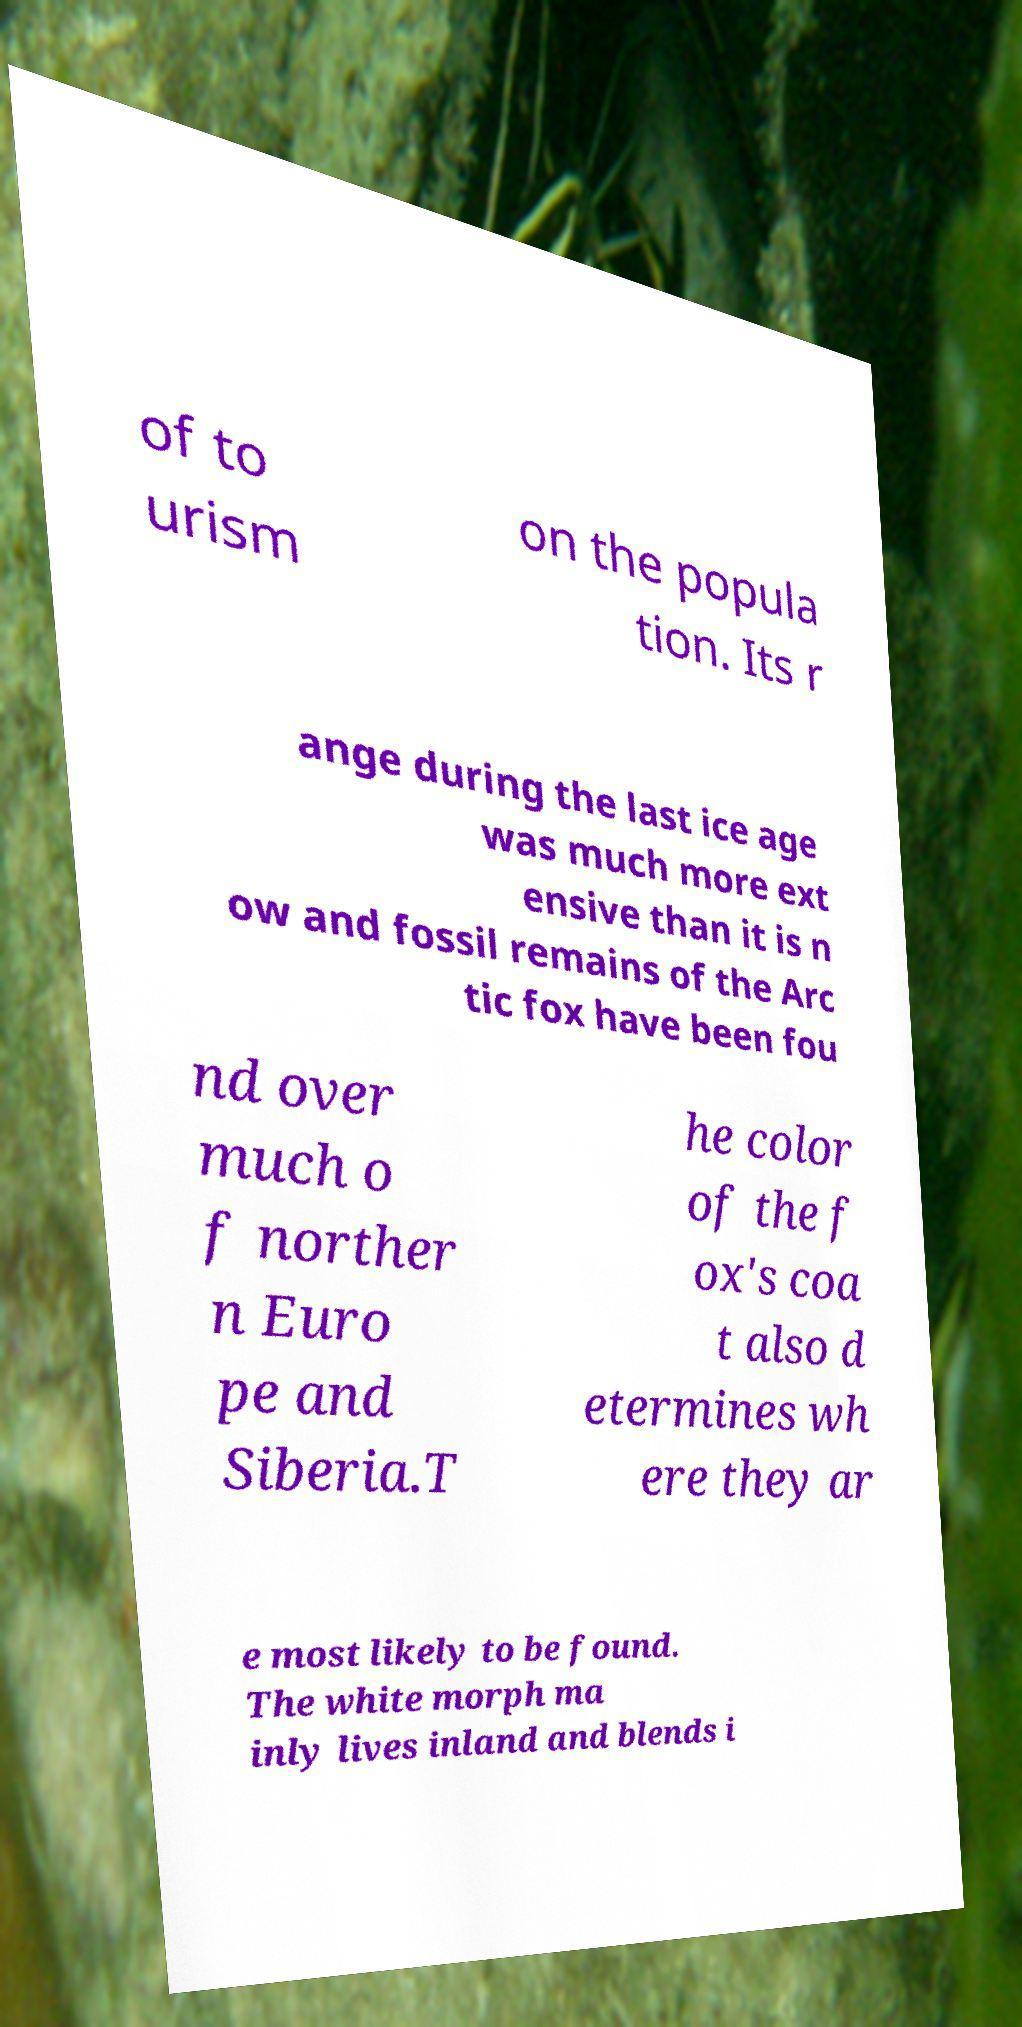For documentation purposes, I need the text within this image transcribed. Could you provide that? of to urism on the popula tion. Its r ange during the last ice age was much more ext ensive than it is n ow and fossil remains of the Arc tic fox have been fou nd over much o f norther n Euro pe and Siberia.T he color of the f ox's coa t also d etermines wh ere they ar e most likely to be found. The white morph ma inly lives inland and blends i 